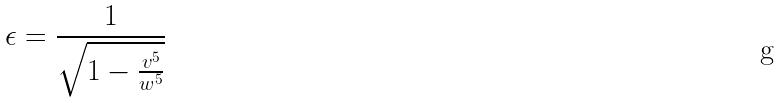Convert formula to latex. <formula><loc_0><loc_0><loc_500><loc_500>\epsilon = \frac { 1 } { \sqrt { 1 - \frac { v ^ { 5 } } { w ^ { 5 } } } }</formula> 